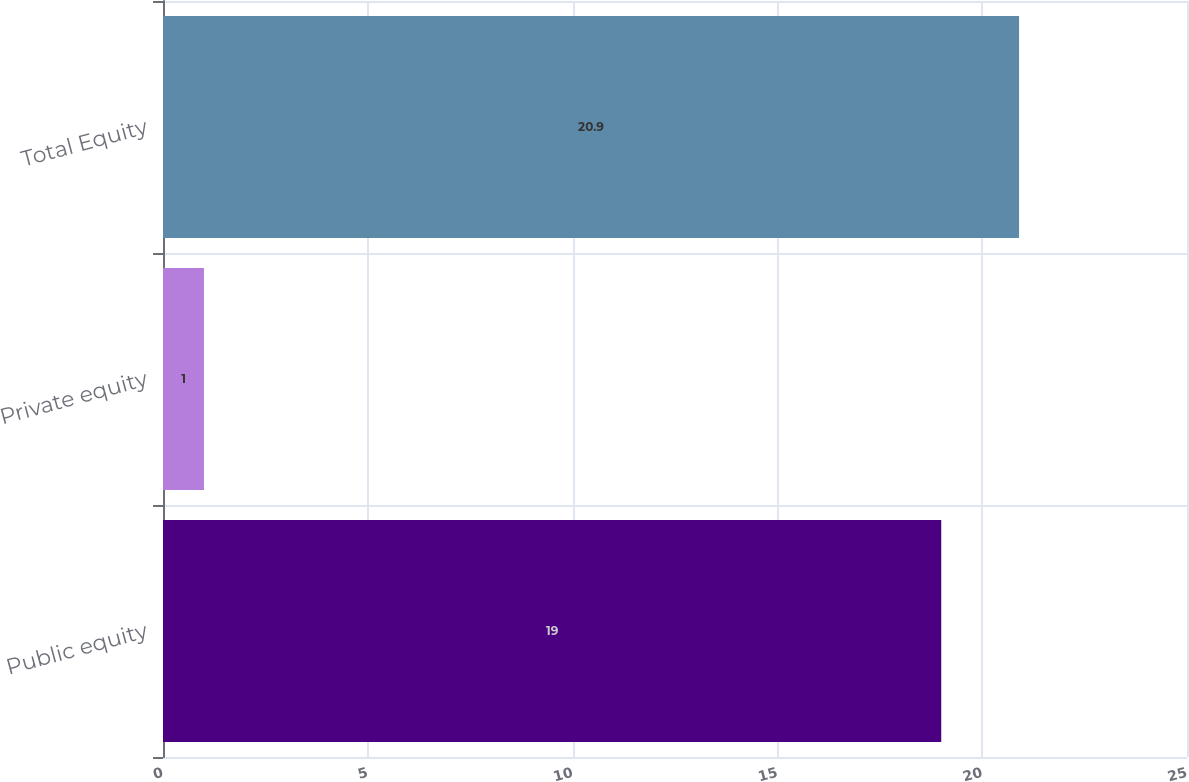<chart> <loc_0><loc_0><loc_500><loc_500><bar_chart><fcel>Public equity<fcel>Private equity<fcel>Total Equity<nl><fcel>19<fcel>1<fcel>20.9<nl></chart> 